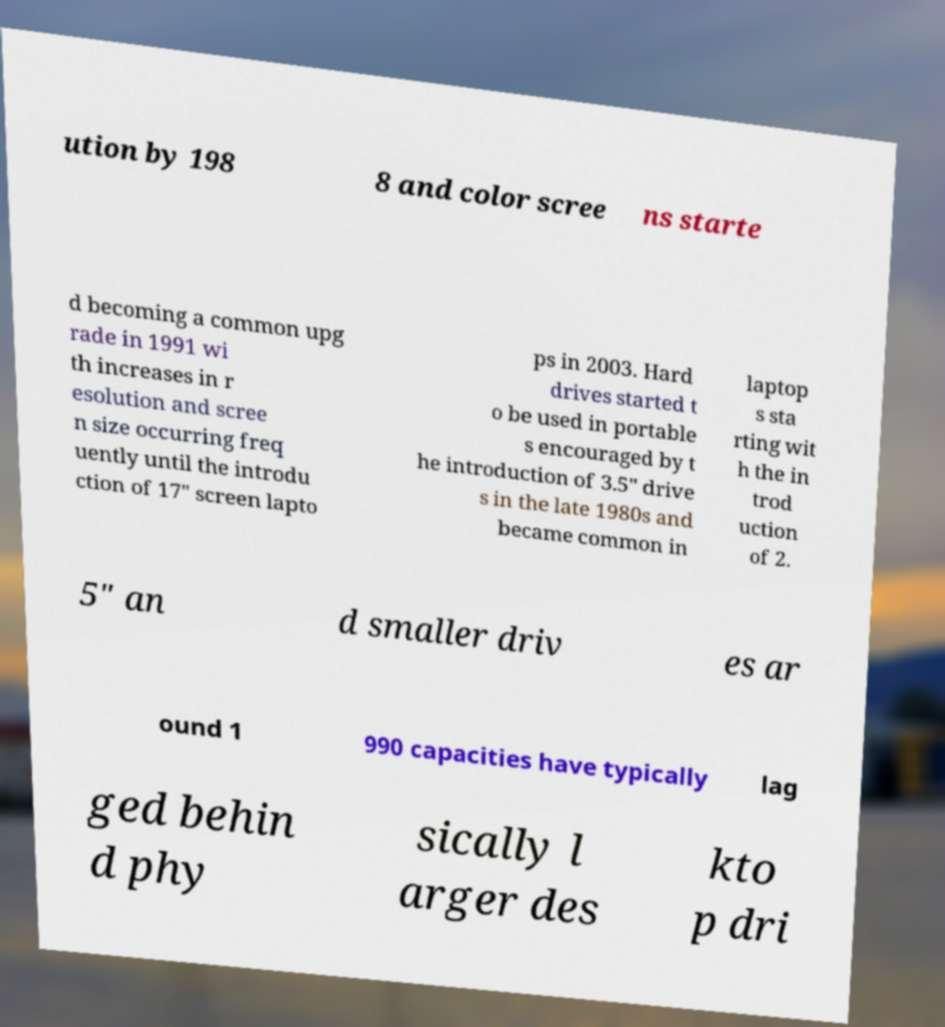Please read and relay the text visible in this image. What does it say? ution by 198 8 and color scree ns starte d becoming a common upg rade in 1991 wi th increases in r esolution and scree n size occurring freq uently until the introdu ction of 17" screen lapto ps in 2003. Hard drives started t o be used in portable s encouraged by t he introduction of 3.5" drive s in the late 1980s and became common in laptop s sta rting wit h the in trod uction of 2. 5" an d smaller driv es ar ound 1 990 capacities have typically lag ged behin d phy sically l arger des kto p dri 